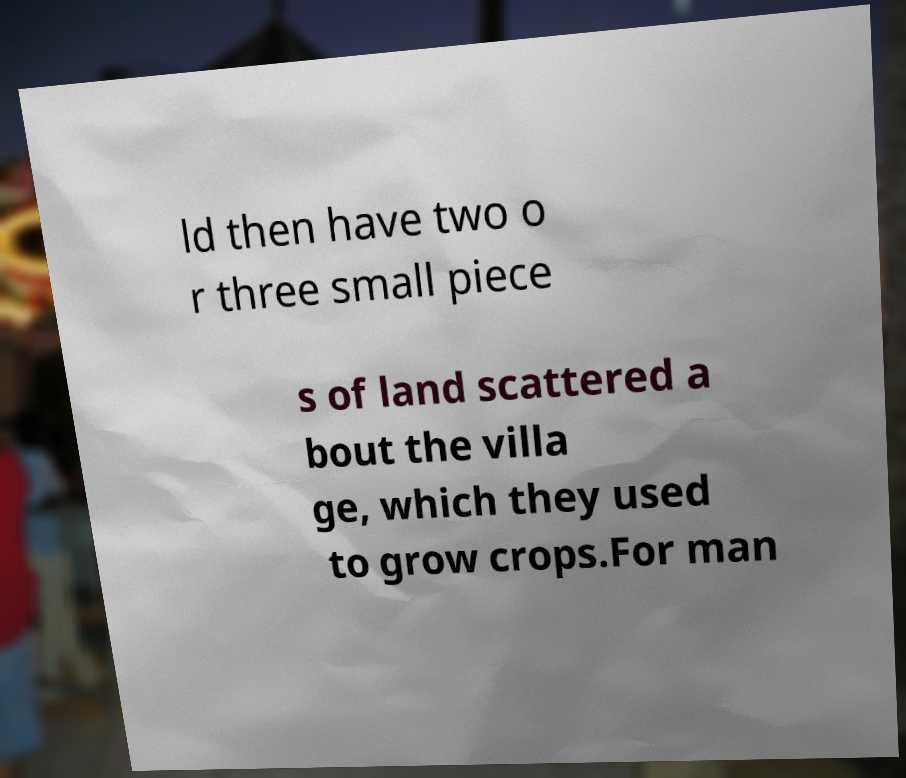Could you extract and type out the text from this image? ld then have two o r three small piece s of land scattered a bout the villa ge, which they used to grow crops.For man 